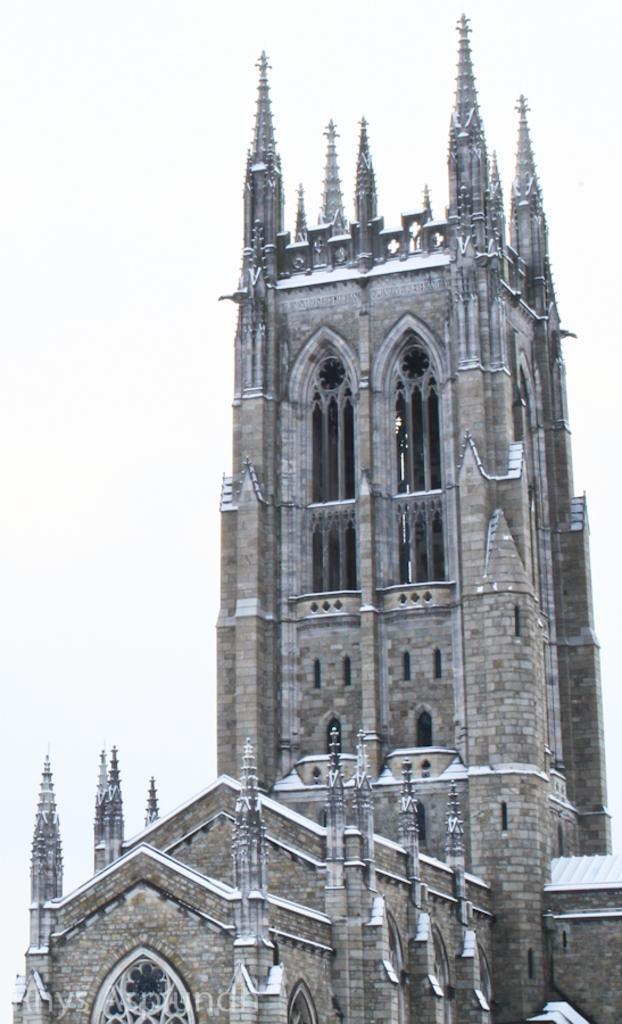How would you summarize this image in a sentence or two? In this picture I can see a building with windows and pillars. 